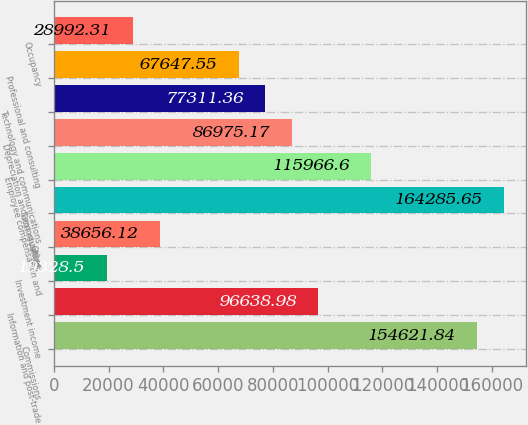<chart> <loc_0><loc_0><loc_500><loc_500><bar_chart><fcel>Commissions<fcel>Information and post-trade<fcel>Investment income<fcel>Other<fcel>Total revenues<fcel>Employee compensation and<fcel>Depreciation and amortization<fcel>Technology and communications<fcel>Professional and consulting<fcel>Occupancy<nl><fcel>154622<fcel>96639<fcel>19328.5<fcel>38656.1<fcel>164286<fcel>115967<fcel>86975.2<fcel>77311.4<fcel>67647.6<fcel>28992.3<nl></chart> 